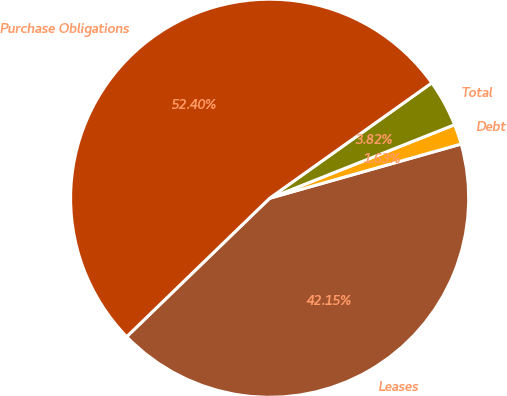<chart> <loc_0><loc_0><loc_500><loc_500><pie_chart><fcel>Leases<fcel>Debt<fcel>Total<fcel>Purchase Obligations<nl><fcel>42.15%<fcel>1.63%<fcel>3.82%<fcel>52.41%<nl></chart> 